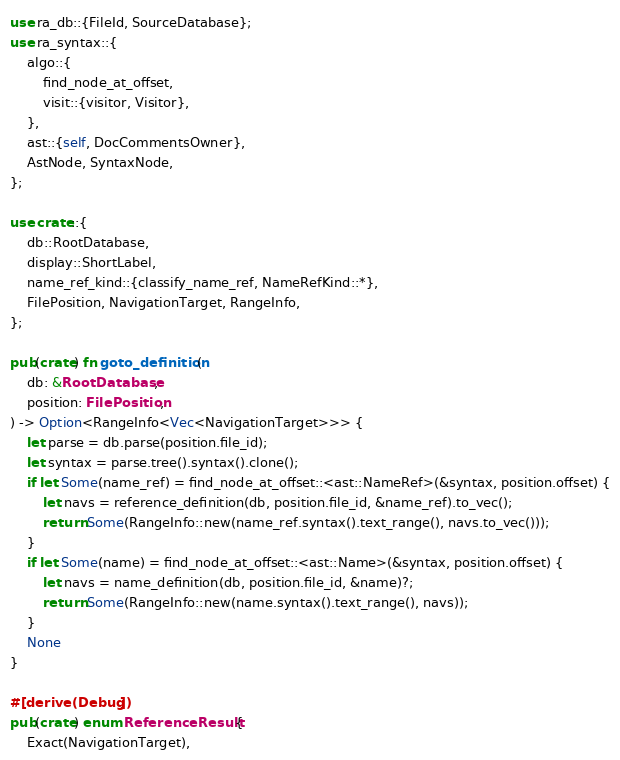Convert code to text. <code><loc_0><loc_0><loc_500><loc_500><_Rust_>use ra_db::{FileId, SourceDatabase};
use ra_syntax::{
    algo::{
        find_node_at_offset,
        visit::{visitor, Visitor},
    },
    ast::{self, DocCommentsOwner},
    AstNode, SyntaxNode,
};

use crate::{
    db::RootDatabase,
    display::ShortLabel,
    name_ref_kind::{classify_name_ref, NameRefKind::*},
    FilePosition, NavigationTarget, RangeInfo,
};

pub(crate) fn goto_definition(
    db: &RootDatabase,
    position: FilePosition,
) -> Option<RangeInfo<Vec<NavigationTarget>>> {
    let parse = db.parse(position.file_id);
    let syntax = parse.tree().syntax().clone();
    if let Some(name_ref) = find_node_at_offset::<ast::NameRef>(&syntax, position.offset) {
        let navs = reference_definition(db, position.file_id, &name_ref).to_vec();
        return Some(RangeInfo::new(name_ref.syntax().text_range(), navs.to_vec()));
    }
    if let Some(name) = find_node_at_offset::<ast::Name>(&syntax, position.offset) {
        let navs = name_definition(db, position.file_id, &name)?;
        return Some(RangeInfo::new(name.syntax().text_range(), navs));
    }
    None
}

#[derive(Debug)]
pub(crate) enum ReferenceResult {
    Exact(NavigationTarget),</code> 